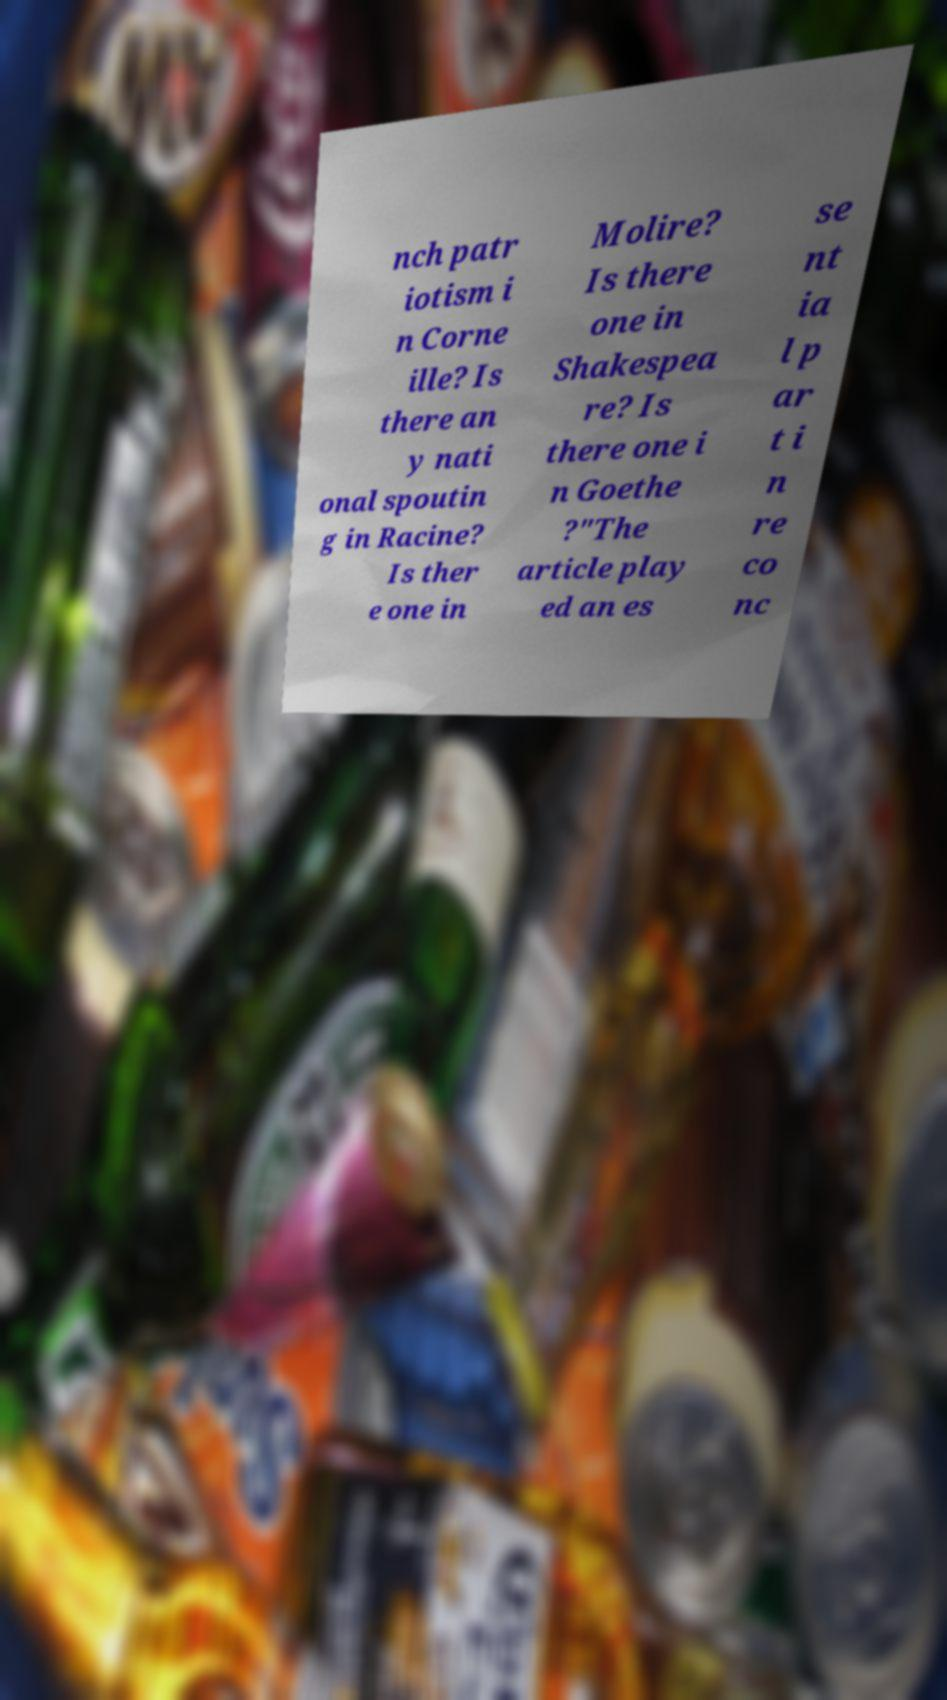Can you accurately transcribe the text from the provided image for me? nch patr iotism i n Corne ille? Is there an y nati onal spoutin g in Racine? Is ther e one in Molire? Is there one in Shakespea re? Is there one i n Goethe ?"The article play ed an es se nt ia l p ar t i n re co nc 